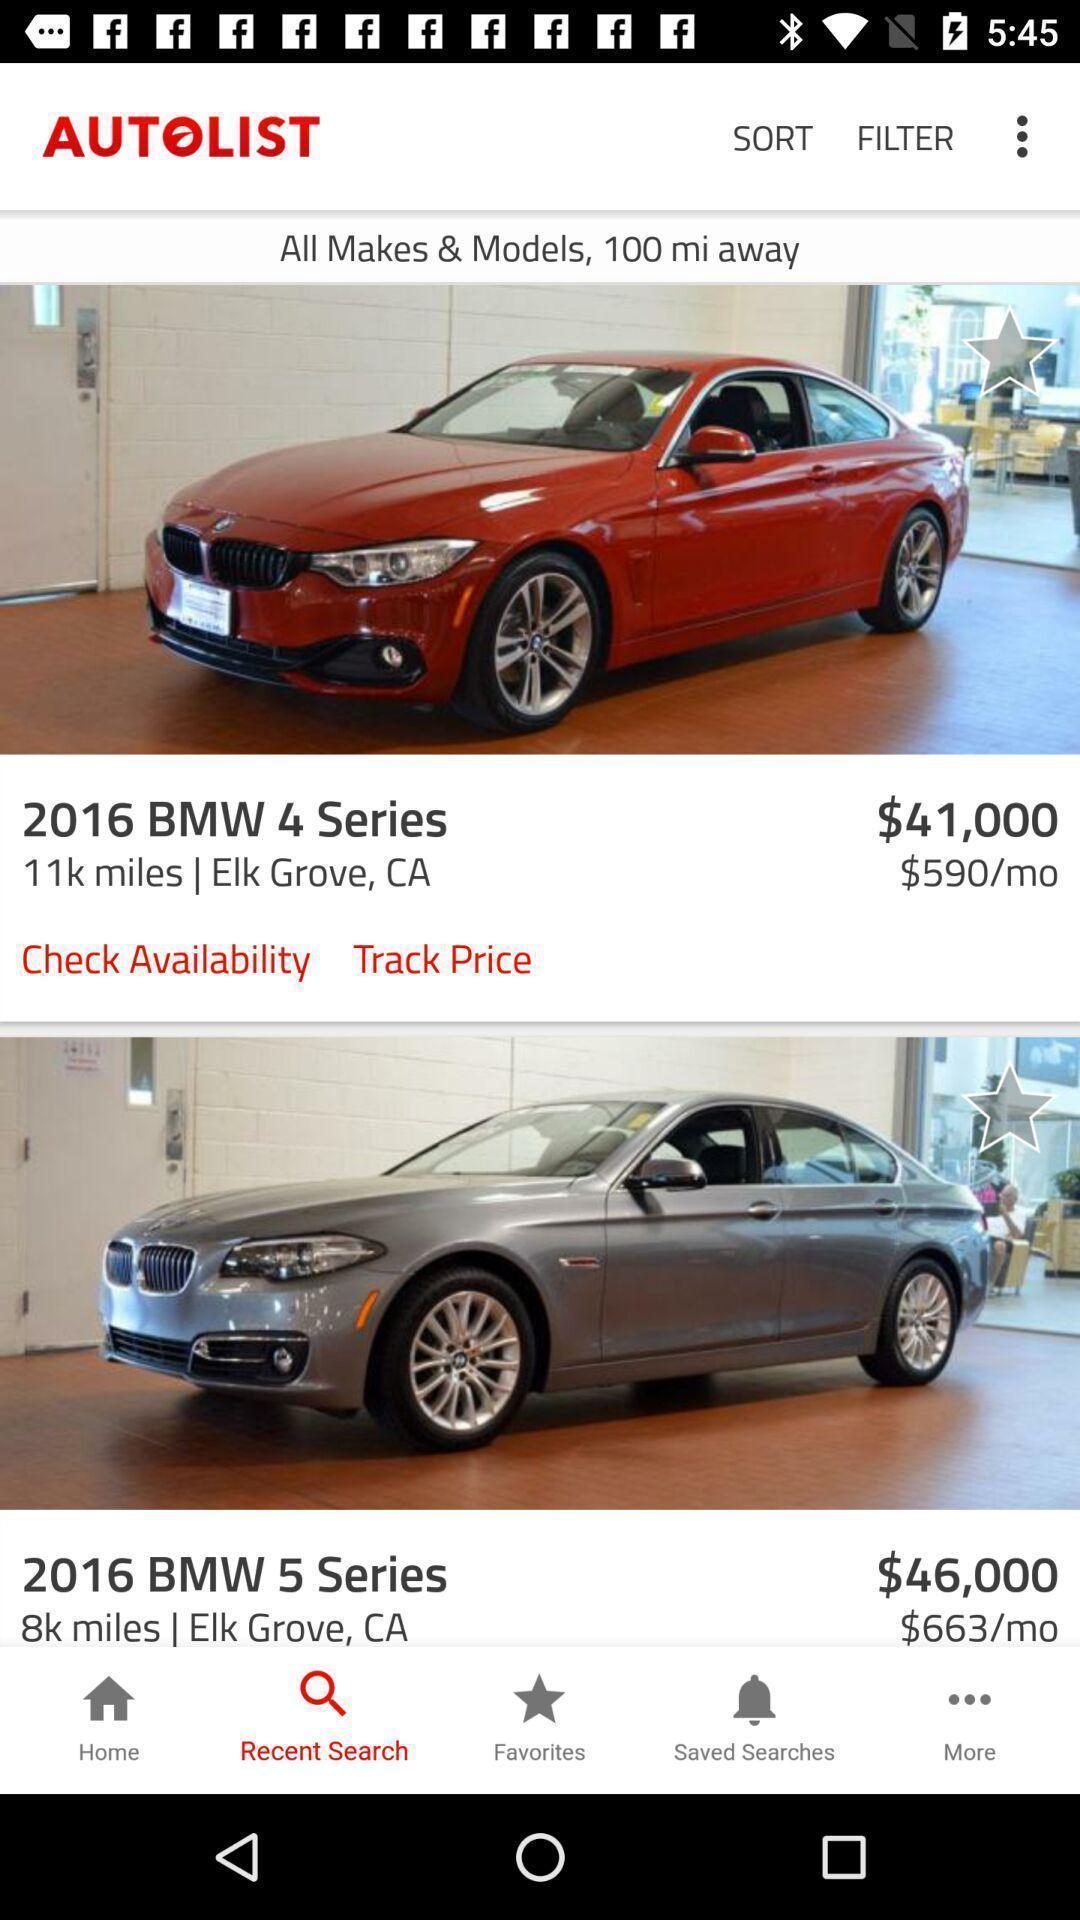Provide a detailed account of this screenshot. Search page of an automobile application. 